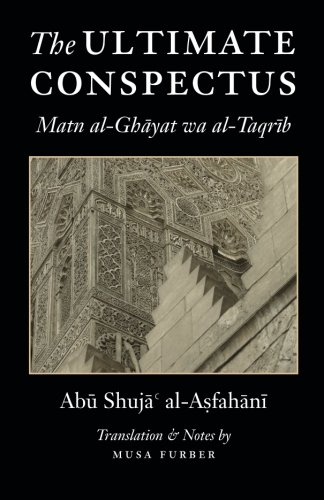Is this book related to Reference? No, this book is not classified under 'Reference' materials; it is primarily an instructive text in the field of Islamic theology. 